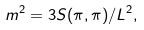<formula> <loc_0><loc_0><loc_500><loc_500>m ^ { 2 } = 3 S ( \pi , \pi ) / L ^ { 2 } ,</formula> 